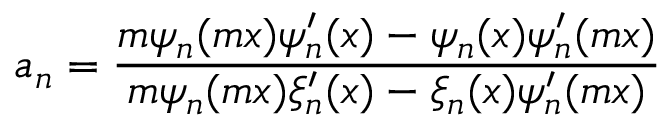<formula> <loc_0><loc_0><loc_500><loc_500>a _ { n } = \frac { m \psi _ { n } ( m x ) \psi _ { n } ^ { \prime } ( x ) - \psi _ { n } ( x ) \psi _ { n } ^ { \prime } ( m x ) } { m \psi _ { n } ( m x ) \xi _ { n } ^ { \prime } ( x ) - \xi _ { n } ( x ) \psi _ { n } ^ { \prime } ( m x ) }</formula> 